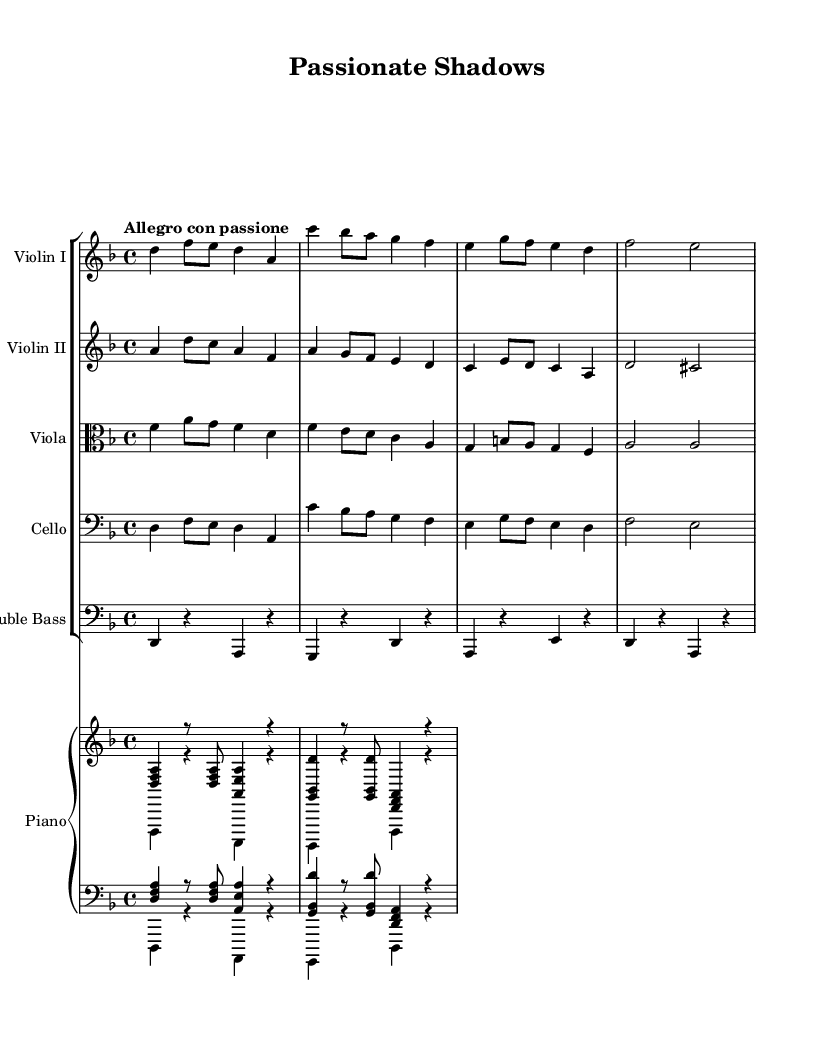What is the key signature of this music? The key signature shows two flats, which indicates that the key is D minor.
Answer: D minor What is the time signature of this sheet music? The time signature is indicated at the beginning of the piece and shows a 4 over 4, meaning there are four beats in each measure.
Answer: 4/4 What is the tempo marking of this piece? The tempo marking at the beginning of the sheet indicates that the piece should be played "Allegro con passione," which conveys a lively and passionate feel.
Answer: Allegro con passione Which instruments are included in the orchestration? By reviewing the staff sections, we can identify violins, viola, cello, double bass, and piano in the orchestration.
Answer: Violin I, Violin II, Viola, Cello, Double Bass, Piano How many beats does the first measure contain? The first measure contains four beats, as indicated by the time signature and the note values presented in the measure, which consist of a quarter note and several eight notes.
Answer: 4 beats Which instrument plays the melody primarily in the first four bars? The first four bars of the piece feature the upper voice, specifically Violin I, which plays the main melodic line prominently.
Answer: Violin I Is there a recurring motif in the rhythms played by the strings? The rhythm pattern seen throughout the string instruments frequently uses a combination of eighth and quarter notes, creating a distinctive tango feel that recurs across the measures.
Answer: Yes, a tango rhythm motif 